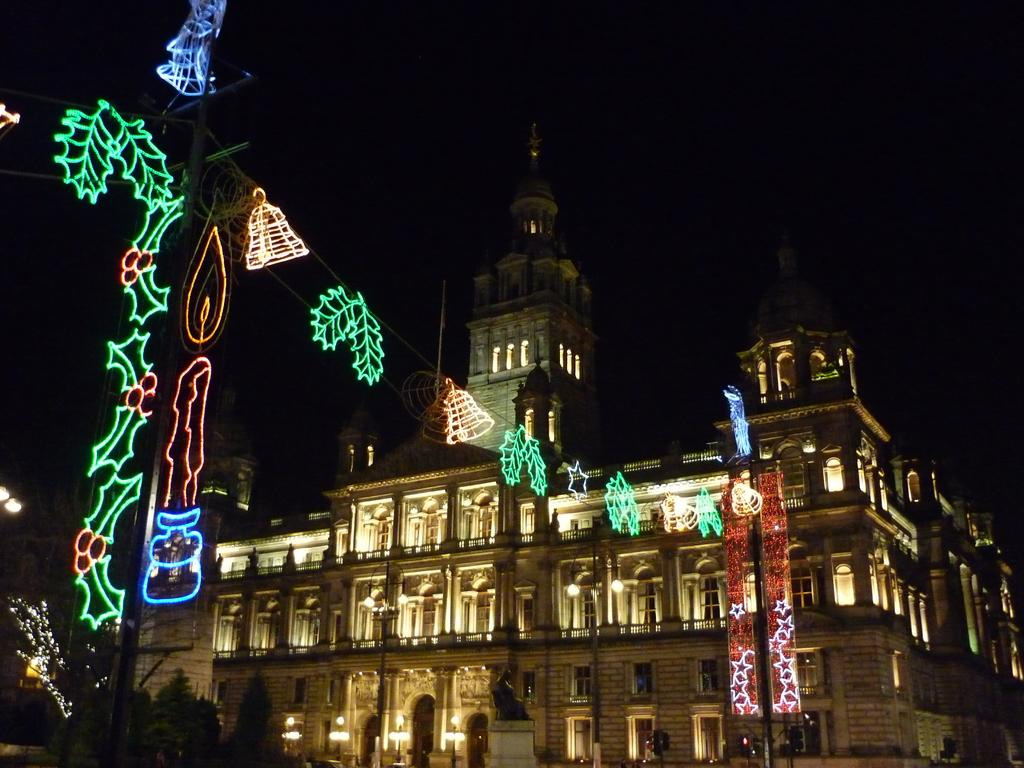What type of building is in the picture? There is a palace in the picture. What feature of the palace is mentioned in the facts? The palace has lights, and there is a decoration of lights at the entrance of the palace. What can be seen in the background of the image? The sky is visible in the background of the image. How would you describe the sky in the image? The sky appears to be dark in the image. Can you see any apples hanging from the trees in the image? There are no trees or apples mentioned in the facts, so we cannot determine if there are any apples in the image. 